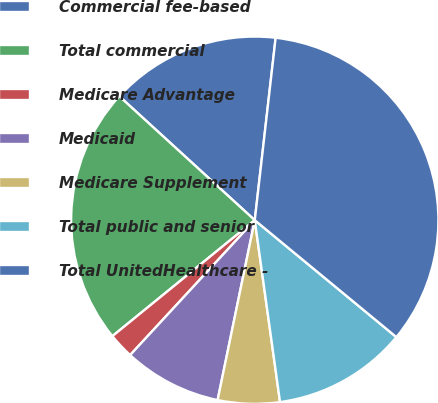<chart> <loc_0><loc_0><loc_500><loc_500><pie_chart><fcel>Commercial fee-based<fcel>Total commercial<fcel>Medicare Advantage<fcel>Medicaid<fcel>Medicare Supplement<fcel>Total public and senior<fcel>Total UnitedHealthcare -<nl><fcel>15.02%<fcel>22.67%<fcel>2.25%<fcel>8.63%<fcel>5.44%<fcel>11.82%<fcel>34.17%<nl></chart> 